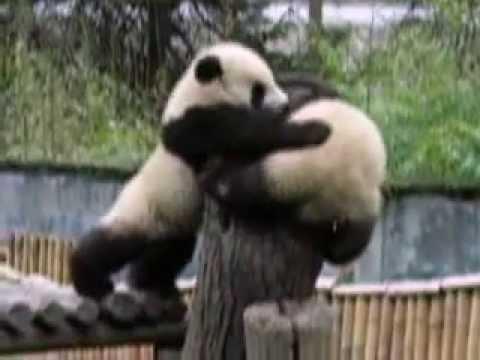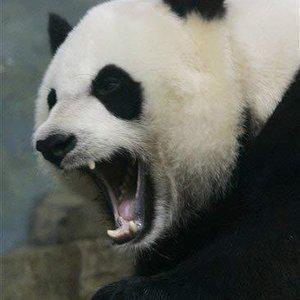The first image is the image on the left, the second image is the image on the right. Evaluate the accuracy of this statement regarding the images: "One image shows two pandas, and the one on the left is standing on a log platform with an arm around the back-turned panda on the right.". Is it true? Answer yes or no. Yes. The first image is the image on the left, the second image is the image on the right. Considering the images on both sides, is "There are four pandas" valid? Answer yes or no. No. 